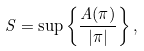<formula> <loc_0><loc_0><loc_500><loc_500>S = \sup \left \{ \frac { A ( \pi ) } { | \pi | } \right \} ,</formula> 